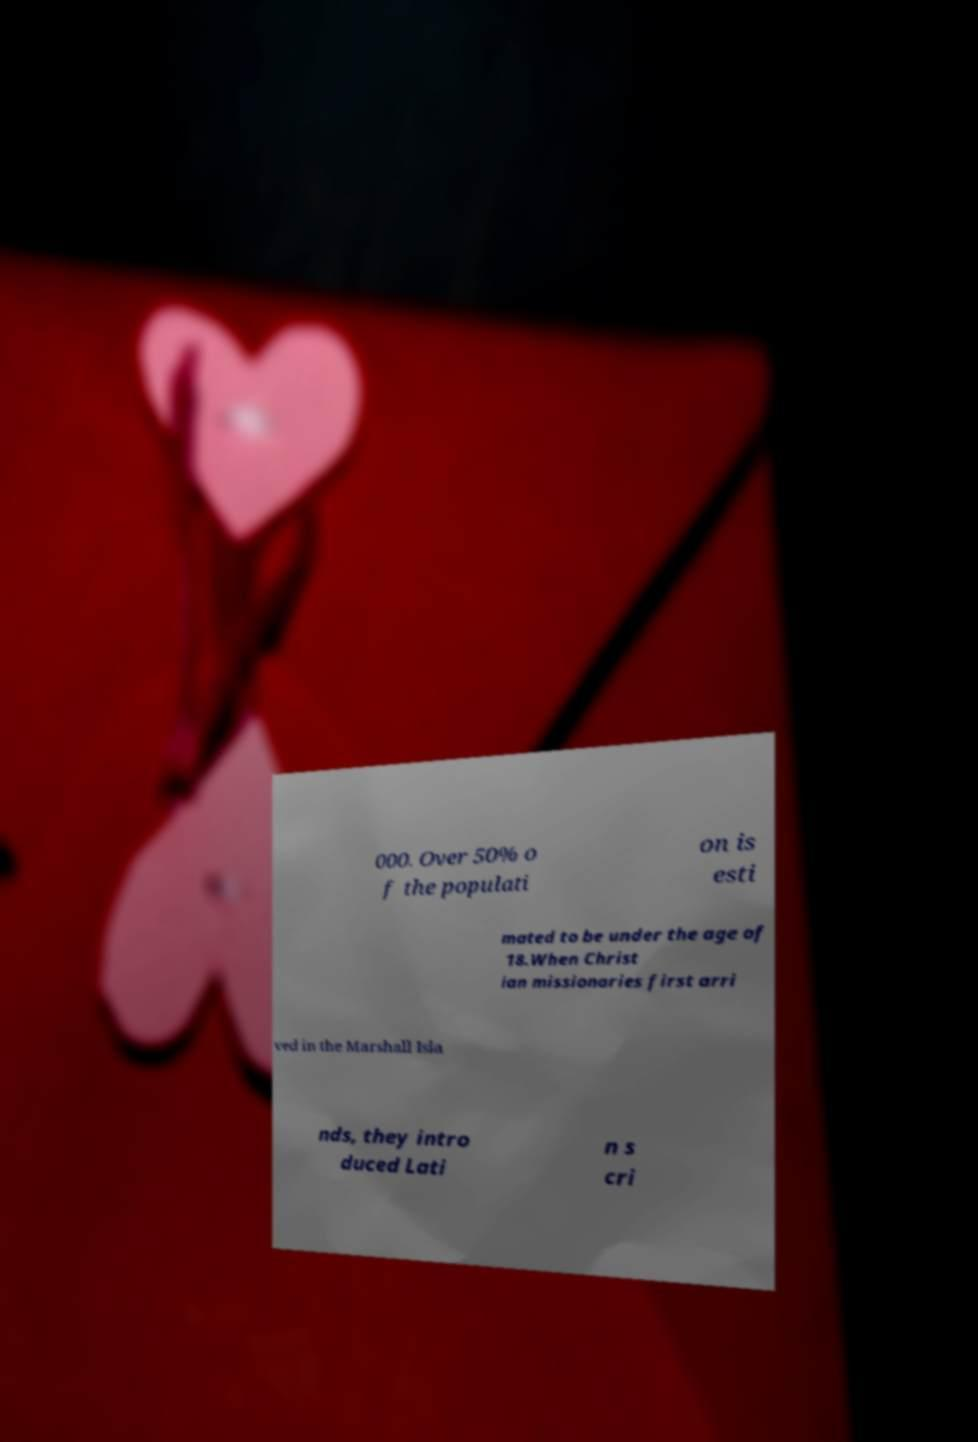I need the written content from this picture converted into text. Can you do that? 000. Over 50% o f the populati on is esti mated to be under the age of 18.When Christ ian missionaries first arri ved in the Marshall Isla nds, they intro duced Lati n s cri 